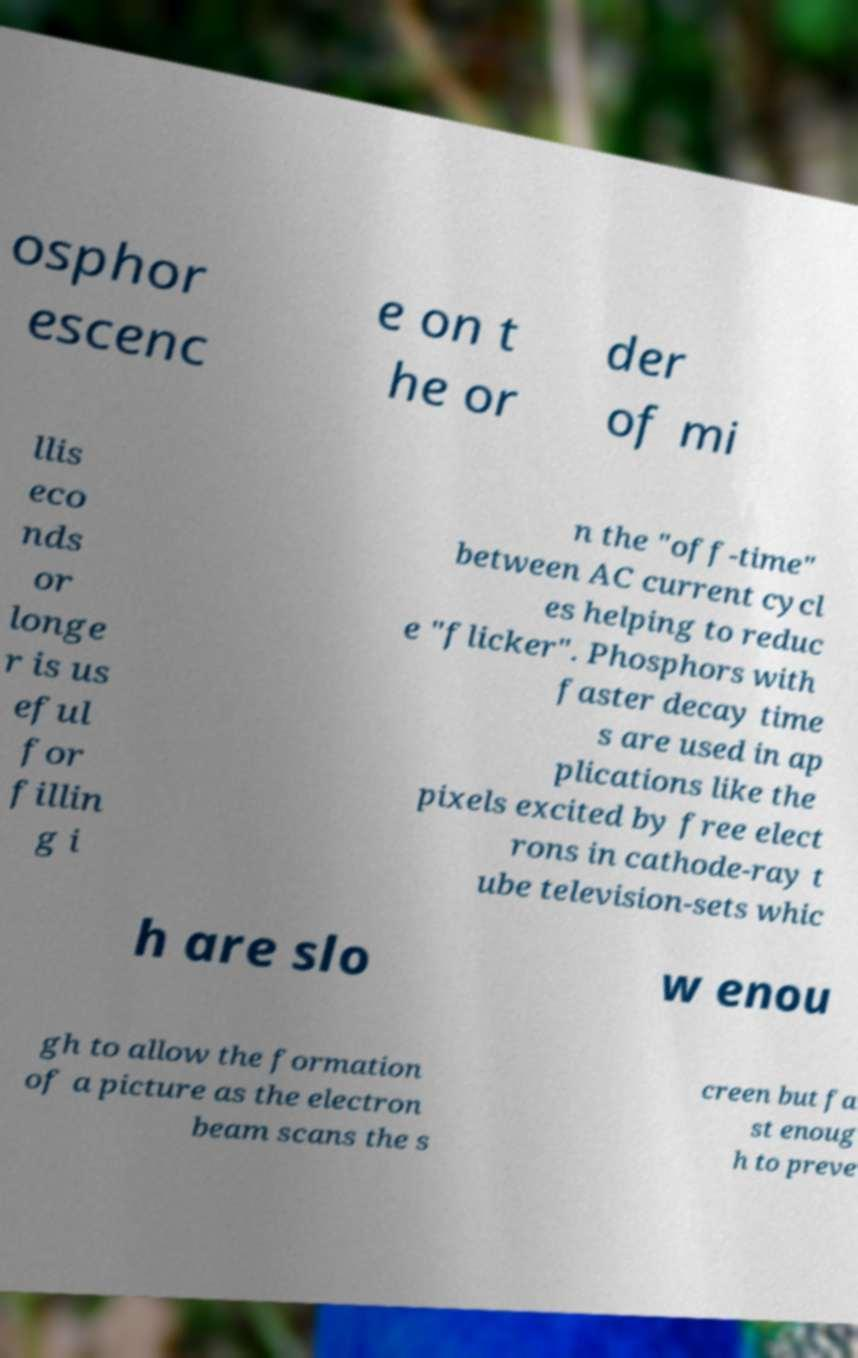There's text embedded in this image that I need extracted. Can you transcribe it verbatim? osphor escenc e on t he or der of mi llis eco nds or longe r is us eful for fillin g i n the "off-time" between AC current cycl es helping to reduc e "flicker". Phosphors with faster decay time s are used in ap plications like the pixels excited by free elect rons in cathode-ray t ube television-sets whic h are slo w enou gh to allow the formation of a picture as the electron beam scans the s creen but fa st enoug h to preve 